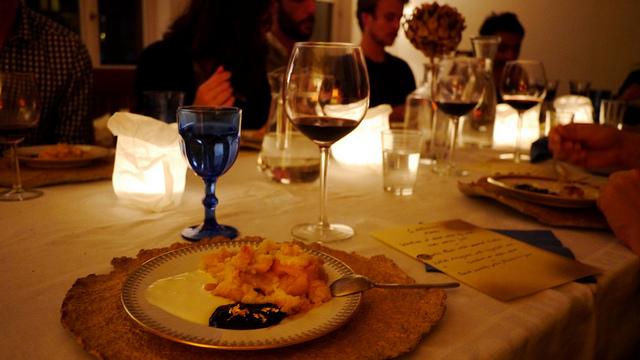How many people are in this scene?
Be succinct. 5. Is the table disorganized?
Be succinct. No. What color is the tablecloth?
Give a very brief answer. White. What is the shredded orange food on the first plate?
Keep it brief. Potatoes. Is this meal sweet?
Give a very brief answer. Yes. Where are the wine glasses?
Quick response, please. On table. Where is the yellow box?
Be succinct. On table. What is in the glass?
Concise answer only. Wine. How many red candles are there?
Be succinct. 0. How many chairs are depicted?
Concise answer only. 0. 